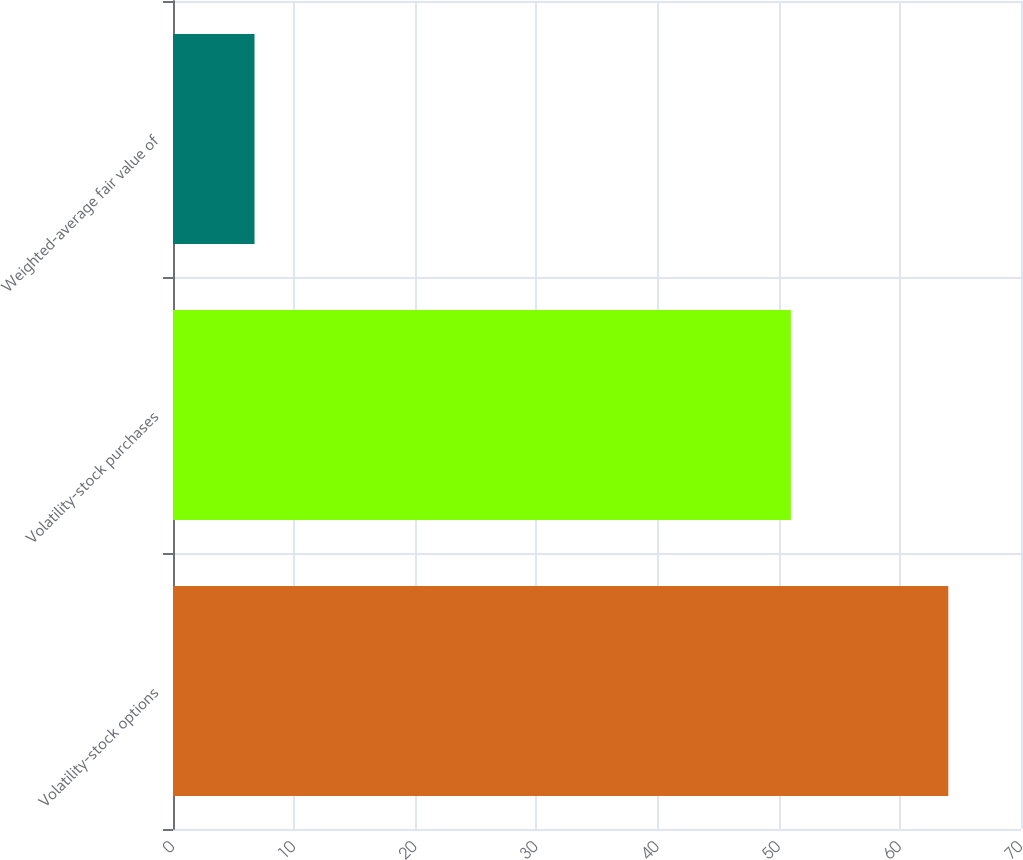Convert chart to OTSL. <chart><loc_0><loc_0><loc_500><loc_500><bar_chart><fcel>Volatility-stock options<fcel>Volatility-stock purchases<fcel>Weighted-average fair value of<nl><fcel>64<fcel>51<fcel>6.73<nl></chart> 